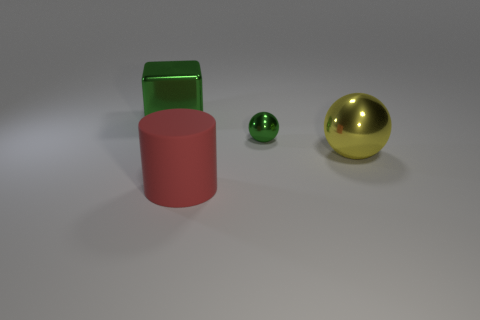How many metallic cubes are the same color as the tiny thing?
Your answer should be very brief. 1. Is there any other thing that is the same shape as the red rubber thing?
Provide a short and direct response. No. How many cylinders are tiny gray shiny objects or green objects?
Give a very brief answer. 0. There is a thing in front of the big sphere; what color is it?
Provide a short and direct response. Red. There is a matte object that is the same size as the green shiny cube; what shape is it?
Make the answer very short. Cylinder. What number of big metal things are to the left of the red rubber thing?
Make the answer very short. 1. What number of things are large blue shiny objects or big cylinders?
Keep it short and to the point. 1. What is the shape of the metal object that is behind the yellow shiny ball and right of the big cylinder?
Keep it short and to the point. Sphere. What number of metallic objects are there?
Provide a short and direct response. 3. There is another sphere that is the same material as the small sphere; what color is it?
Make the answer very short. Yellow. 